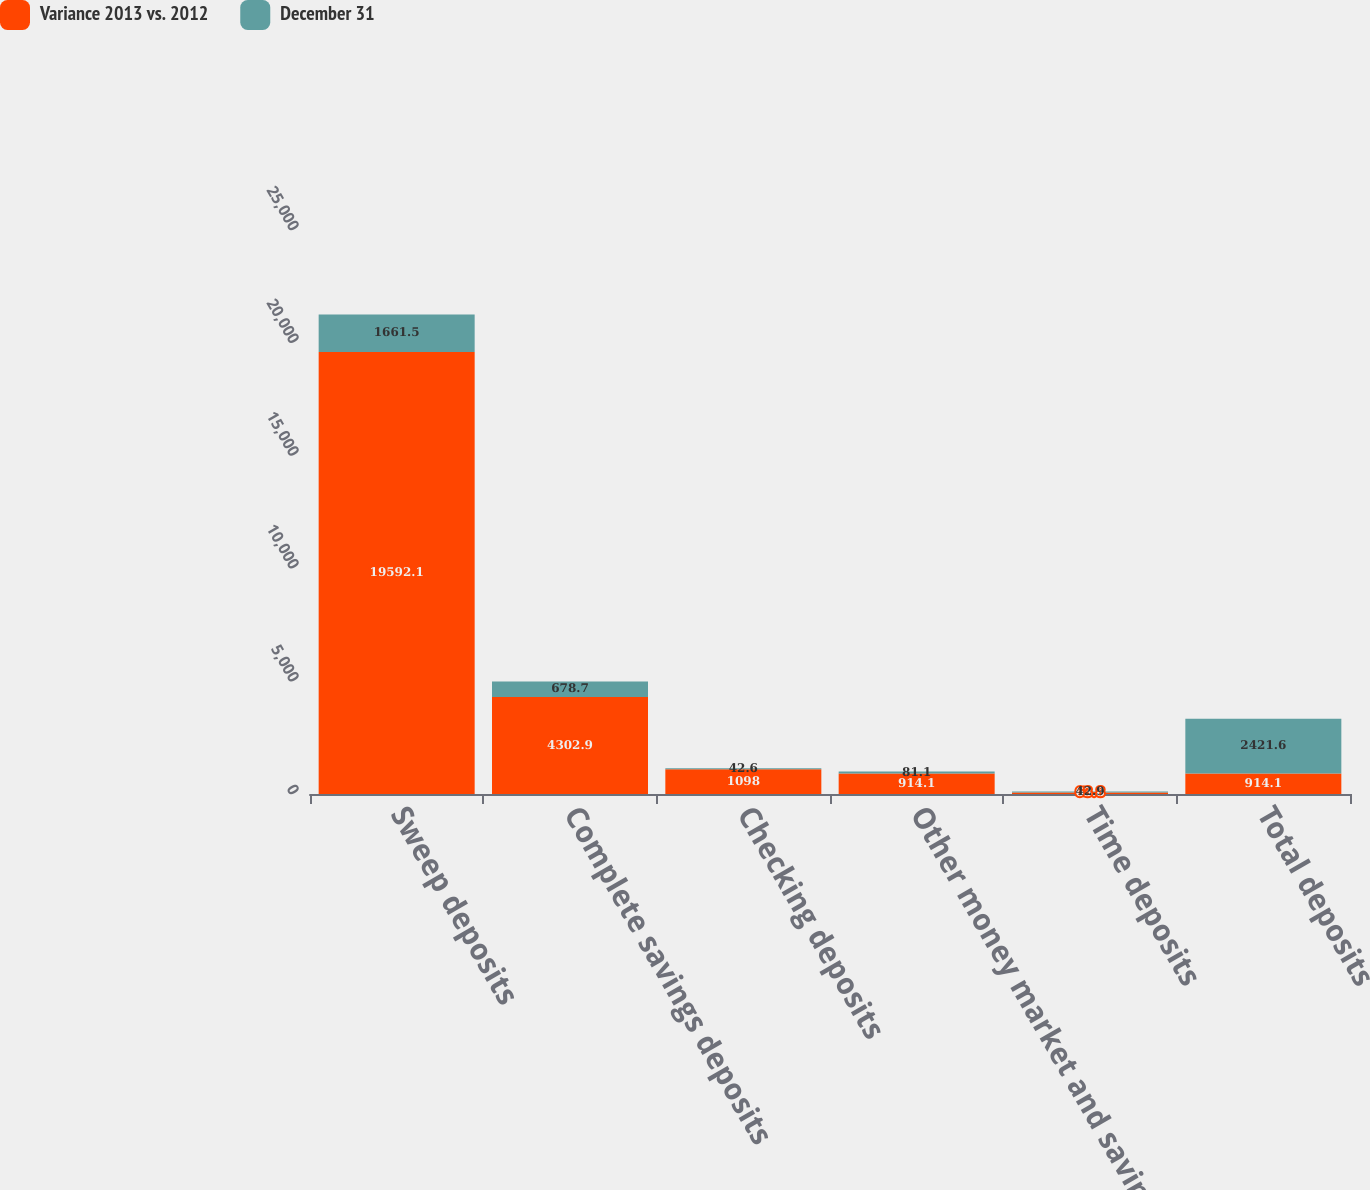<chart> <loc_0><loc_0><loc_500><loc_500><stacked_bar_chart><ecel><fcel>Sweep deposits<fcel>Complete savings deposits<fcel>Checking deposits<fcel>Other money market and savings<fcel>Time deposits<fcel>Total deposits<nl><fcel>Variance 2013 vs. 2012<fcel>19592.1<fcel>4302.9<fcel>1098<fcel>914.1<fcel>63.8<fcel>914.1<nl><fcel>December 31<fcel>1661.5<fcel>678.7<fcel>42.6<fcel>81.1<fcel>42.9<fcel>2421.6<nl></chart> 